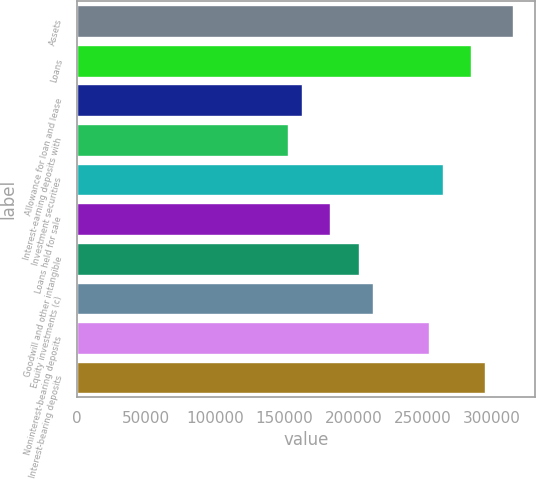<chart> <loc_0><loc_0><loc_500><loc_500><bar_chart><fcel>Assets<fcel>Loans<fcel>Allowance for loan and lease<fcel>Interest-earning deposits with<fcel>Investment securities<fcel>Loans held for sale<fcel>Goodwill and other intangible<fcel>Equity investments (c)<fcel>Noninterest-bearing deposits<fcel>Interest-bearing deposits<nl><fcel>315636<fcel>285091<fcel>162910<fcel>152729<fcel>264728<fcel>183274<fcel>203637<fcel>213819<fcel>254546<fcel>295273<nl></chart> 